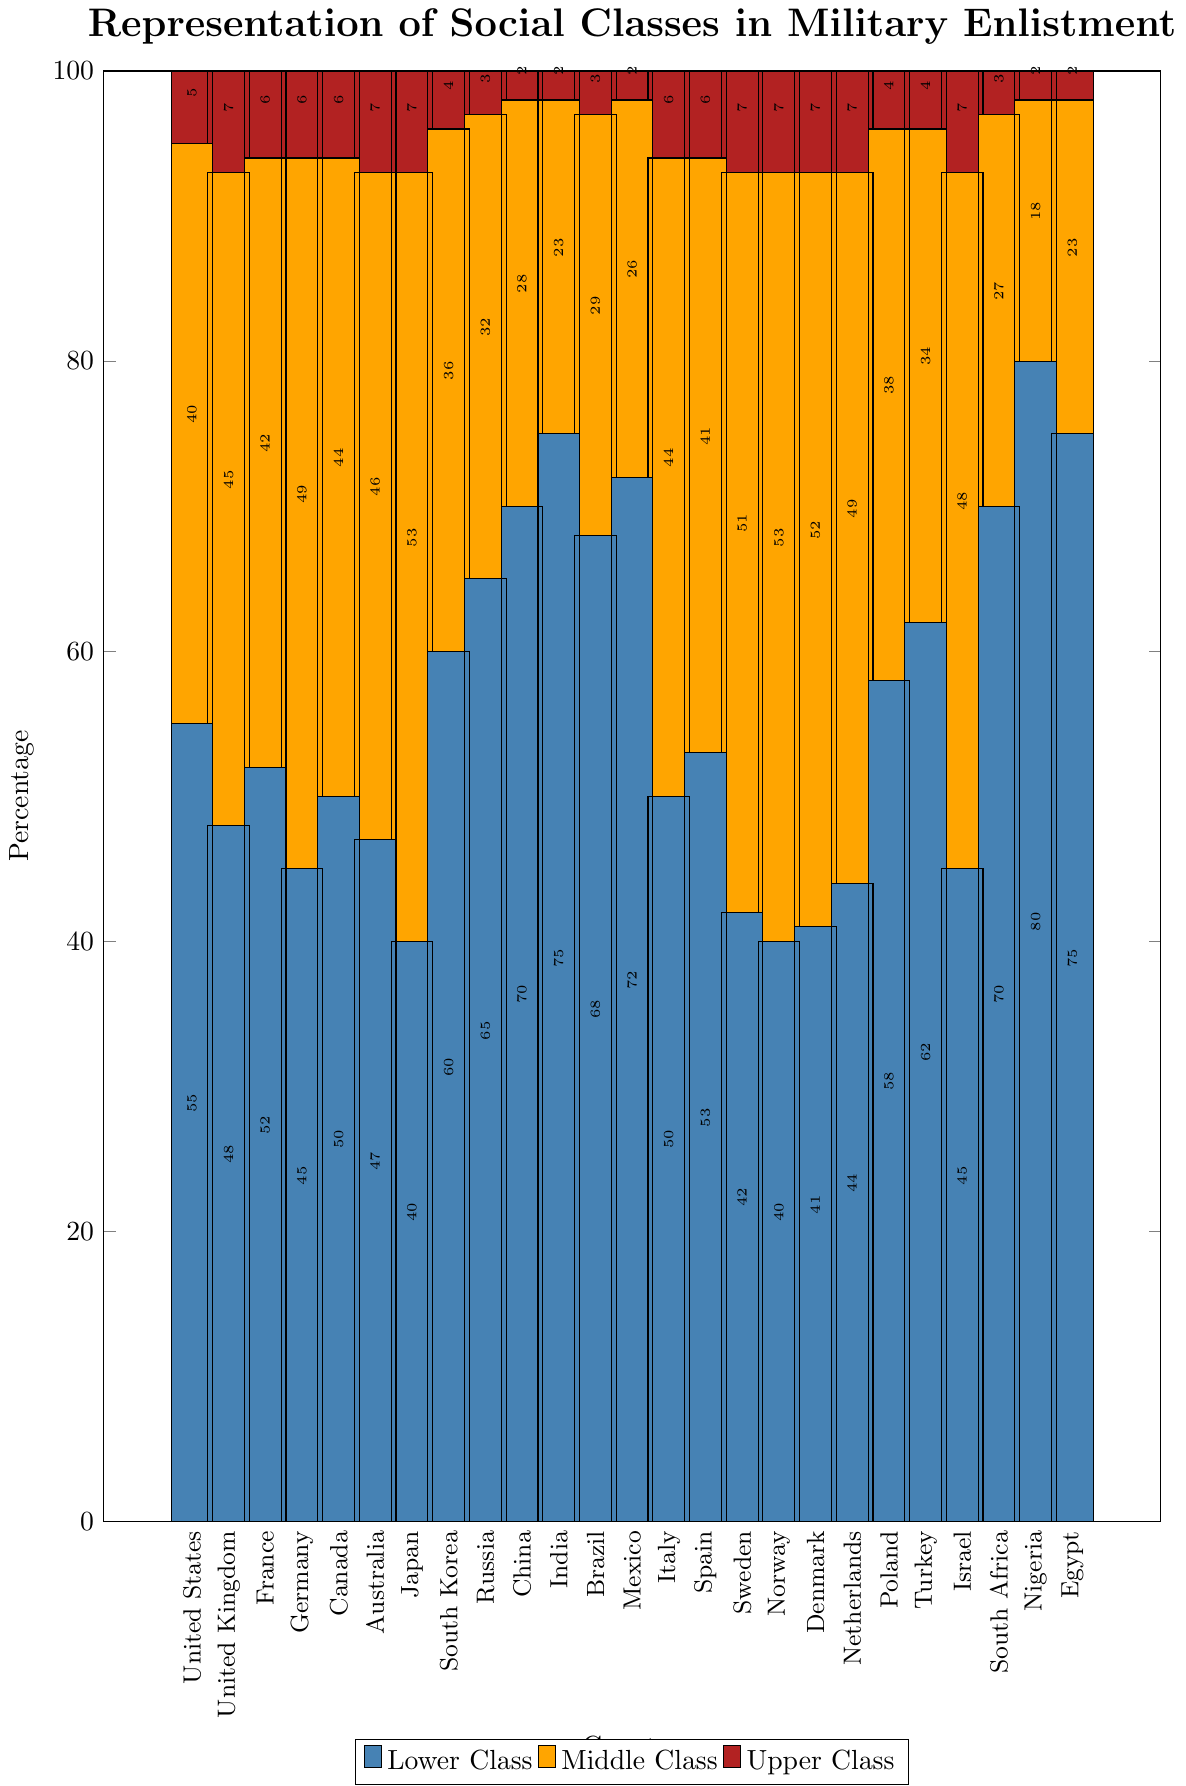Which country has the highest percentage of lower-class enlistment? Observe the bar representing the lower-class enlistment and identify the bar that reaches the highest percentage. Nigeria has the tallest blue bar, indicating 80%.
Answer: Nigeria Which country has the lowest percentage of upper-class enlistment? Look for the smallest portion of red bars and identify the country with the shortest red bar. China, India, Mexico, Nigeria, and Egypt all have the smallest red bar portion at 2%.
Answer: China, India, Mexico, Nigeria, or Egypt Which countries have an equal percentage of middle-class enlistment at 49%? Scan the middle-class (orange) bars and find the countries where the bars reach 49%. Germany and Netherlands both have their middle-class bars reaching 49%.
Answer: Germany, Netherlands By how much does the lower-class enlistment in Russia differ from that in the United States? Find the heights of the lower-class bars for Russia and the United States. Russia is at 65%, and the United States is at 55%. Calculate the difference: 65% - 55% = 10%.
Answer: 10% In which countries does the middle-class representation exceed the lower-class by more than 10%? Compare the middle-class (orange) and lower-class (blue) bars for each country. Identify countries where the orange bar is significantly higher by more than 10% compared to the blue bar. Japan, Sweden, Norway, and Denmark exceed by more than 10%.
Answer: Japan, Sweden, Norway, Denmark What is the difference between the highest and lowest percentage values for the middle class across all countries? Identify the highest and lowest values for the orange bars. The highest is 53% (Japan, Norway), and the lowest is 18% (Nigeria). Calculate the difference: 53% - 18% = 35%.
Answer: 35% What is the combined percentage of lower-class enlistment in China and India? Look at the lower-class (blue) bars for China and India. China has 70%, and India has 75%. Combine these: 70% + 75% = 145%.
Answer: 145% Which country's middle-class enlistment is closest to 40%? Examine the orange middle-class bars and find the country near 40%. The United States is exactly at 40%.
Answer: United States How much larger is the lower-class enlistment in Mexico compared to Italy? Identify the lower-class enlistment percentages for Mexico and Italy by observing the blue bars. Mexico is at 72%, and Italy is at 50%. Calculate the difference: 72% - 50% = 22%.
Answer: 22% What is the average percentage of upper-class enlistment across all countries? Add up all the red bar percentages for each country and divide by the number of countries (25). The total sum is 133%. Calculate the average: 133% / 25 = 5.32%.
Answer: 5.32% 